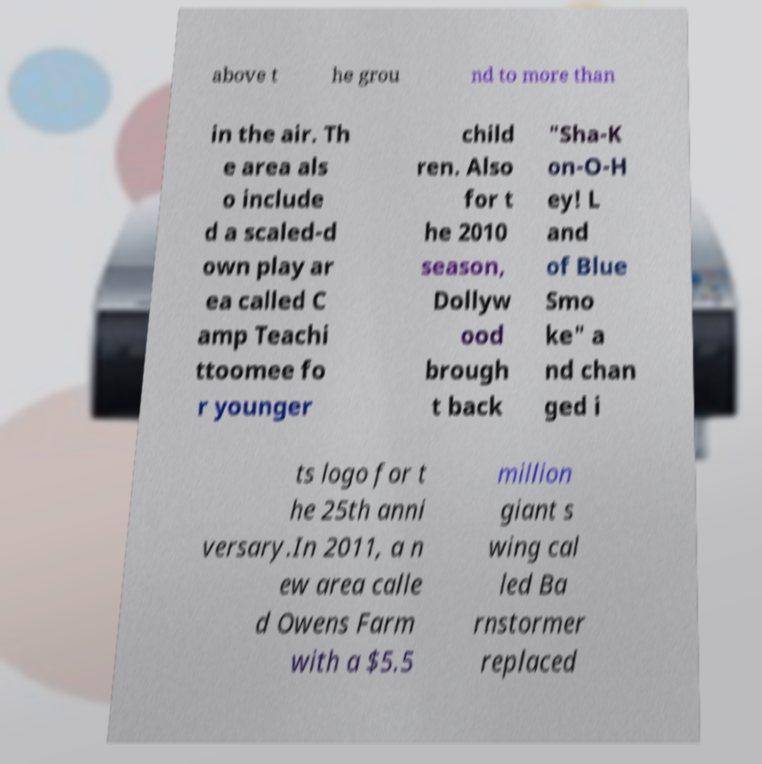Could you extract and type out the text from this image? above t he grou nd to more than in the air. Th e area als o include d a scaled-d own play ar ea called C amp Teachi ttoomee fo r younger child ren. Also for t he 2010 season, Dollyw ood brough t back "Sha-K on-O-H ey! L and of Blue Smo ke" a nd chan ged i ts logo for t he 25th anni versary.In 2011, a n ew area calle d Owens Farm with a $5.5 million giant s wing cal led Ba rnstormer replaced 